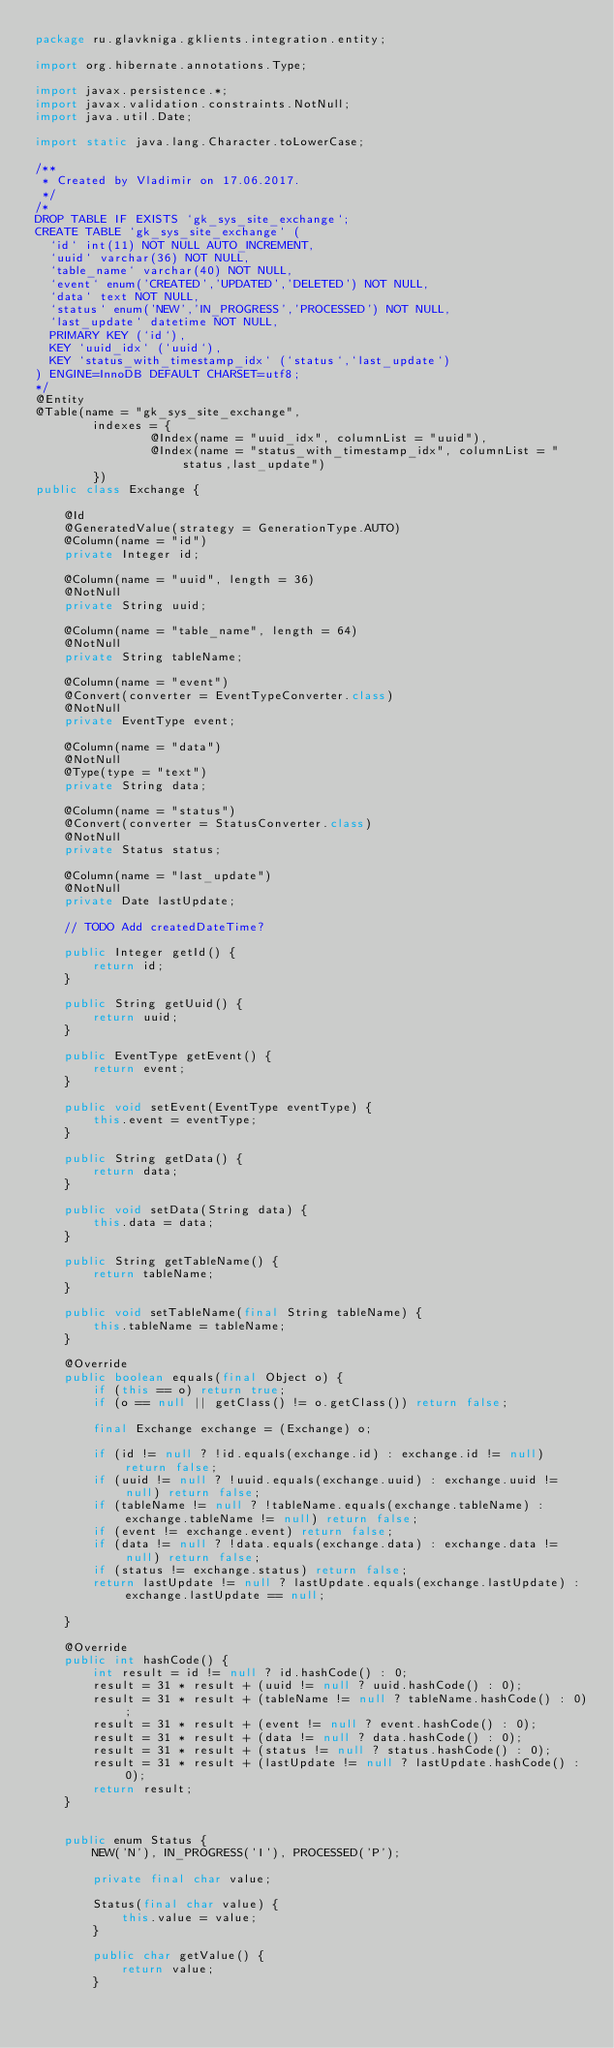<code> <loc_0><loc_0><loc_500><loc_500><_Java_>package ru.glavkniga.gklients.integration.entity;

import org.hibernate.annotations.Type;

import javax.persistence.*;
import javax.validation.constraints.NotNull;
import java.util.Date;

import static java.lang.Character.toLowerCase;

/**
 * Created by Vladimir on 17.06.2017.
 */
/*
DROP TABLE IF EXISTS `gk_sys_site_exchange`;
CREATE TABLE `gk_sys_site_exchange` (
  `id` int(11) NOT NULL AUTO_INCREMENT,
  `uuid` varchar(36) NOT NULL,
  `table_name` varchar(40) NOT NULL,
  `event` enum('CREATED','UPDATED','DELETED') NOT NULL,
  `data` text NOT NULL,
  `status` enum('NEW','IN_PROGRESS','PROCESSED') NOT NULL,
  `last_update` datetime NOT NULL,
  PRIMARY KEY (`id`),
  KEY `uuid_idx` (`uuid`),
  KEY `status_with_timestamp_idx` (`status`,`last_update`)
) ENGINE=InnoDB DEFAULT CHARSET=utf8;
*/
@Entity
@Table(name = "gk_sys_site_exchange",
        indexes = {
                @Index(name = "uuid_idx", columnList = "uuid"),
                @Index(name = "status_with_timestamp_idx", columnList = "status,last_update")
        })
public class Exchange {

    @Id
    @GeneratedValue(strategy = GenerationType.AUTO)
    @Column(name = "id")
    private Integer id;

    @Column(name = "uuid", length = 36)
    @NotNull
    private String uuid;

    @Column(name = "table_name", length = 64)
    @NotNull
    private String tableName;

    @Column(name = "event")
    @Convert(converter = EventTypeConverter.class)
    @NotNull
    private EventType event;

    @Column(name = "data")
    @NotNull
    @Type(type = "text")
    private String data;

    @Column(name = "status")
    @Convert(converter = StatusConverter.class)
    @NotNull
    private Status status;

    @Column(name = "last_update")
    @NotNull
    private Date lastUpdate;

    // TODO Add createdDateTime?

    public Integer getId() {
        return id;
    }

    public String getUuid() {
        return uuid;
    }

    public EventType getEvent() {
        return event;
    }

    public void setEvent(EventType eventType) {
        this.event = eventType;
    }

    public String getData() {
        return data;
    }

    public void setData(String data) {
        this.data = data;
    }

    public String getTableName() {
        return tableName;
    }

    public void setTableName(final String tableName) {
        this.tableName = tableName;
    }

    @Override
    public boolean equals(final Object o) {
        if (this == o) return true;
        if (o == null || getClass() != o.getClass()) return false;

        final Exchange exchange = (Exchange) o;

        if (id != null ? !id.equals(exchange.id) : exchange.id != null) return false;
        if (uuid != null ? !uuid.equals(exchange.uuid) : exchange.uuid != null) return false;
        if (tableName != null ? !tableName.equals(exchange.tableName) : exchange.tableName != null) return false;
        if (event != exchange.event) return false;
        if (data != null ? !data.equals(exchange.data) : exchange.data != null) return false;
        if (status != exchange.status) return false;
        return lastUpdate != null ? lastUpdate.equals(exchange.lastUpdate) : exchange.lastUpdate == null;

    }

    @Override
    public int hashCode() {
        int result = id != null ? id.hashCode() : 0;
        result = 31 * result + (uuid != null ? uuid.hashCode() : 0);
        result = 31 * result + (tableName != null ? tableName.hashCode() : 0);
        result = 31 * result + (event != null ? event.hashCode() : 0);
        result = 31 * result + (data != null ? data.hashCode() : 0);
        result = 31 * result + (status != null ? status.hashCode() : 0);
        result = 31 * result + (lastUpdate != null ? lastUpdate.hashCode() : 0);
        return result;
    }


    public enum Status {
        NEW('N'), IN_PROGRESS('I'), PROCESSED('P');

        private final char value;

        Status(final char value) {
            this.value = value;
        }

        public char getValue() {
            return value;
        }
</code> 